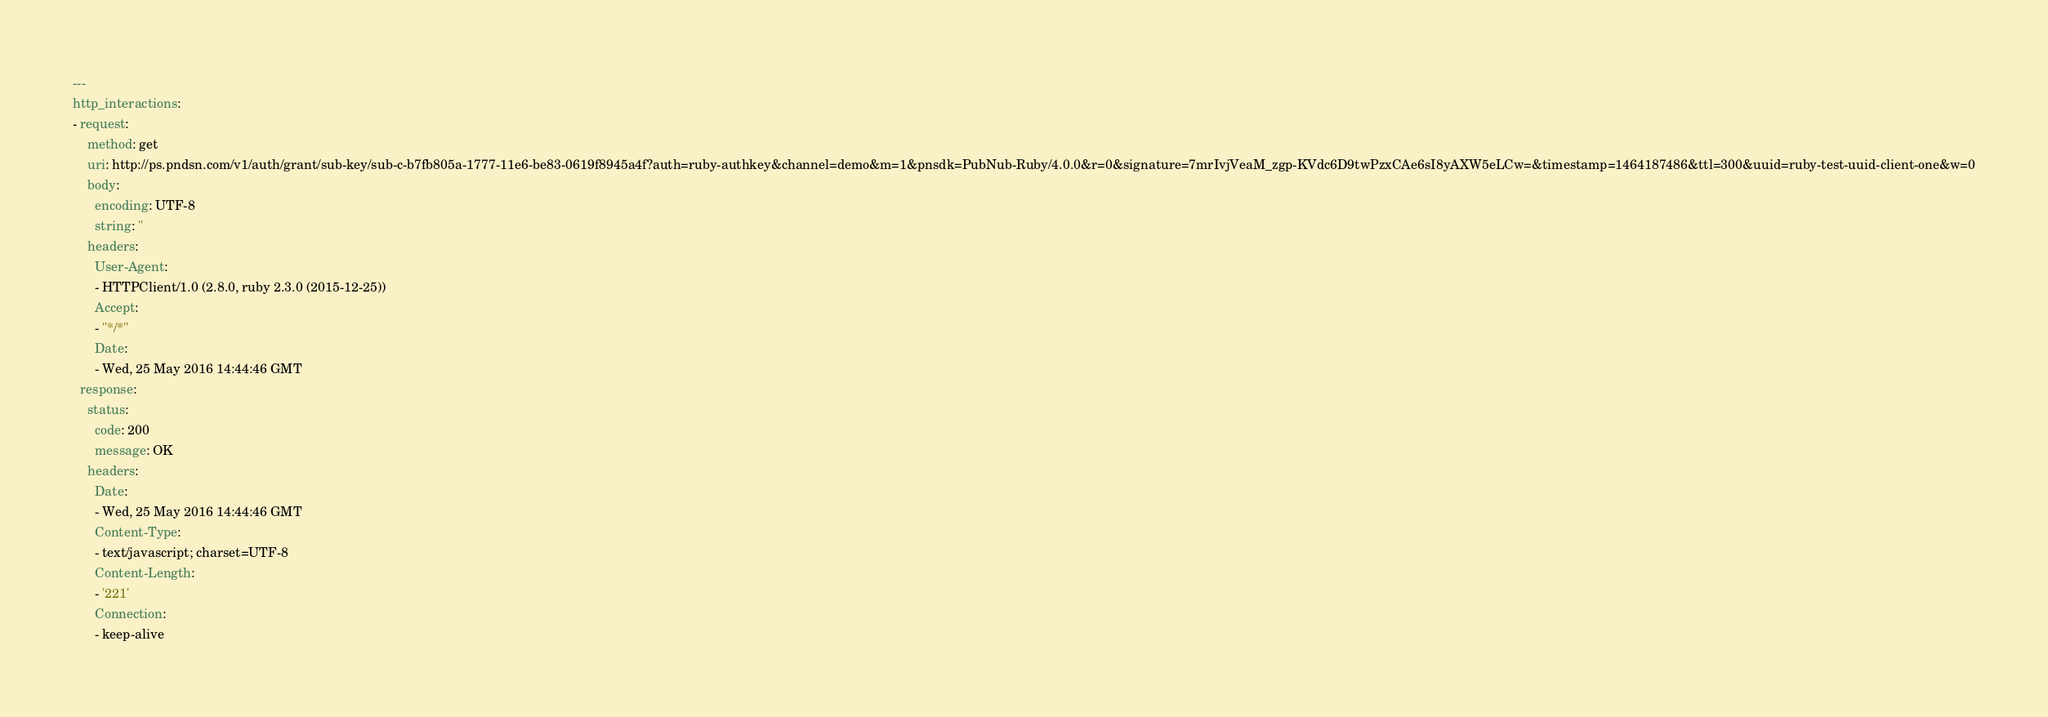<code> <loc_0><loc_0><loc_500><loc_500><_YAML_>---
http_interactions:
- request:
    method: get
    uri: http://ps.pndsn.com/v1/auth/grant/sub-key/sub-c-b7fb805a-1777-11e6-be83-0619f8945a4f?auth=ruby-authkey&channel=demo&m=1&pnsdk=PubNub-Ruby/4.0.0&r=0&signature=7mrIvjVeaM_zgp-KVdc6D9twPzxCAe6sI8yAXW5eLCw=&timestamp=1464187486&ttl=300&uuid=ruby-test-uuid-client-one&w=0
    body:
      encoding: UTF-8
      string: ''
    headers:
      User-Agent:
      - HTTPClient/1.0 (2.8.0, ruby 2.3.0 (2015-12-25))
      Accept:
      - "*/*"
      Date:
      - Wed, 25 May 2016 14:44:46 GMT
  response:
    status:
      code: 200
      message: OK
    headers:
      Date:
      - Wed, 25 May 2016 14:44:46 GMT
      Content-Type:
      - text/javascript; charset=UTF-8
      Content-Length:
      - '221'
      Connection:
      - keep-alive</code> 